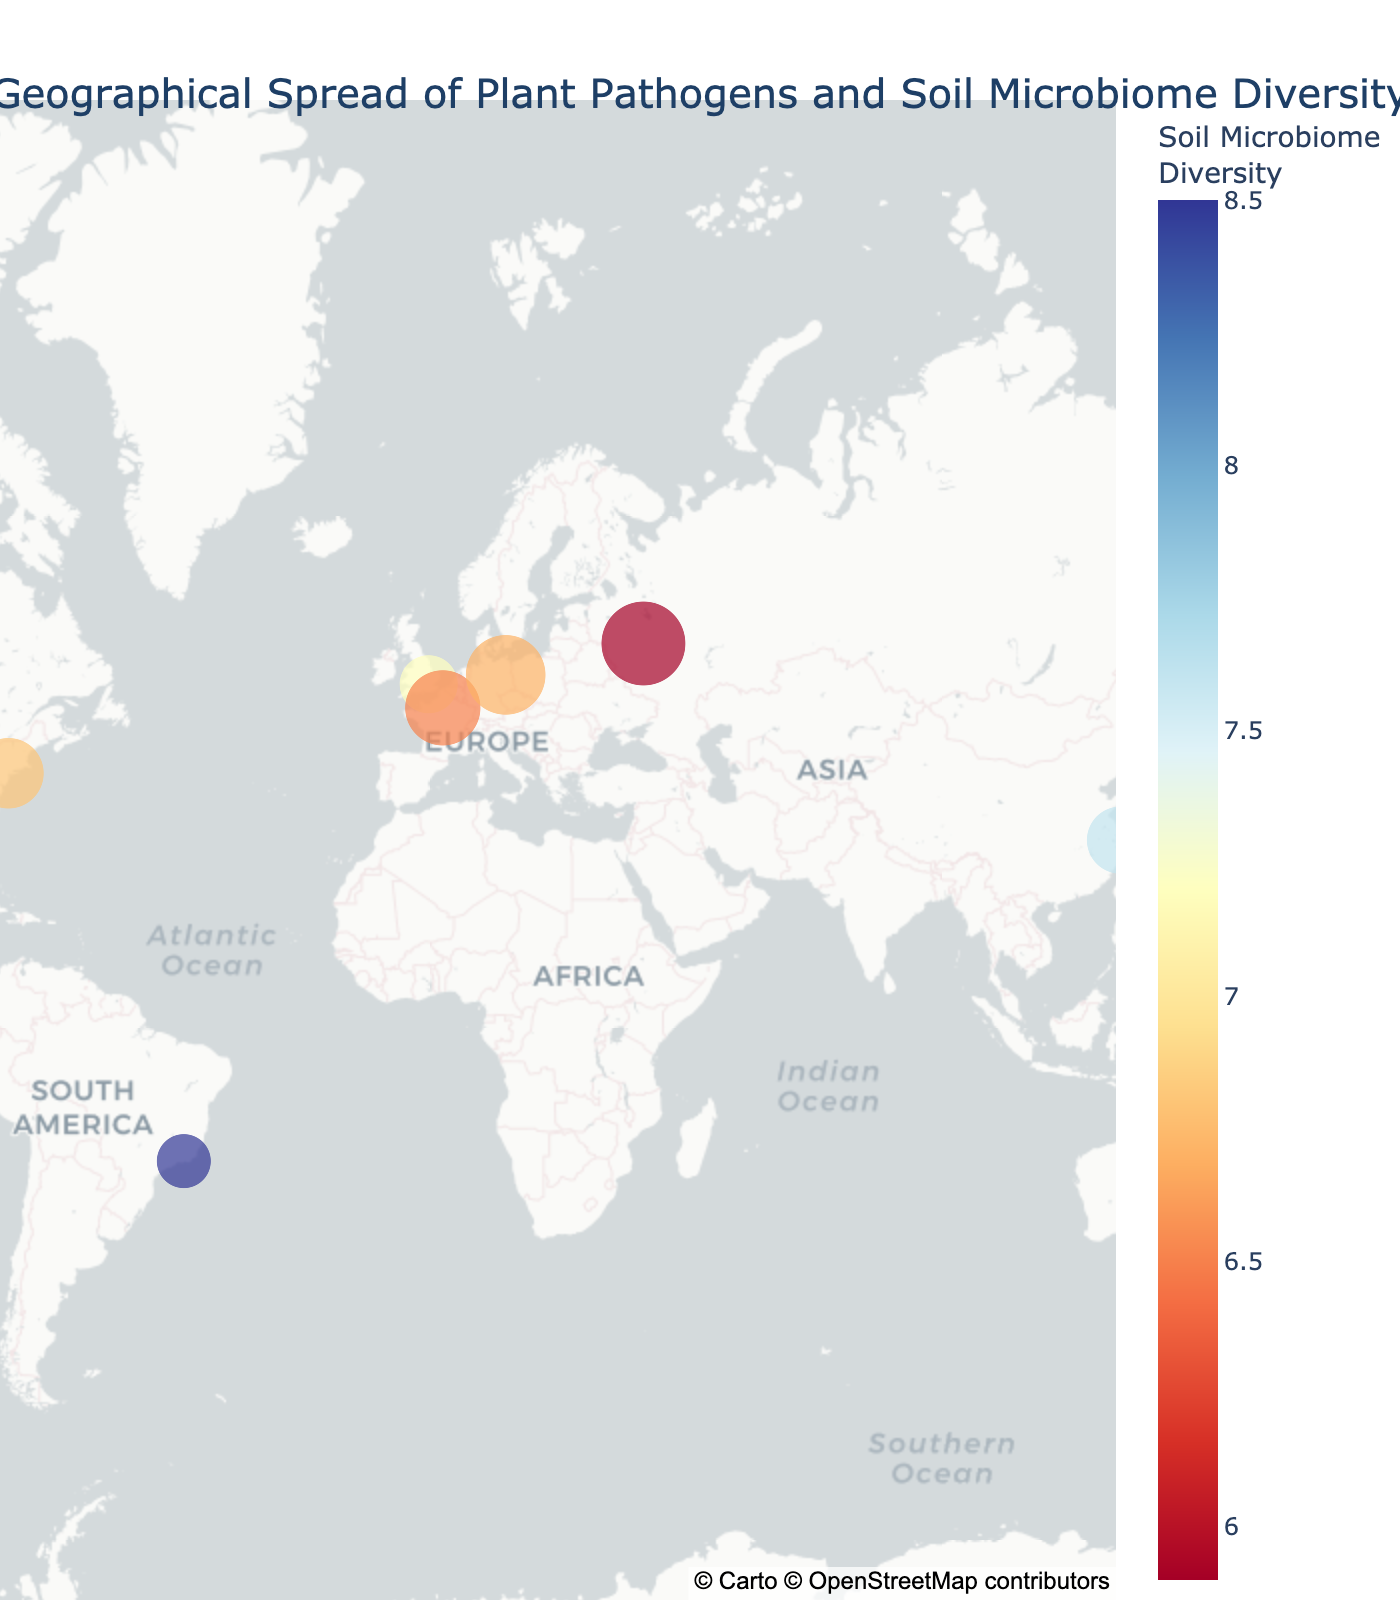What is the title of the plot? The title is displayed at the top of the plot, centered and slightly above the map. It provides a summary of the plot's content.
Answer: Geographical Spread of Plant Pathogens and Soil Microbiome Diversity How many data points are displayed on the map? Each data point represents a city with associated pathogen data, and these are visually represented as points on the map. By counting these points, we can find the total number.
Answer: 10 Which location has the highest soil microbiome diversity? Look for the data point with the highest value in the color scale representing soil microbiome diversity. The hover label can help identify the exact location.
Answer: Rio de Janeiro What is the infection rate for the pathogen in Sydney? Hover over the data point representing Sydney to display the additional information, which includes the infection rate for the pathogen in that location.
Answer: 0.18 Compare the soil microbiome diversity between London and New York. Which is higher? Hover over the data points for London and New York individually to see their soil microbiome diversity values. Compare the two values to determine which is higher.
Answer: London What is the sum of the infection rates for Berlin and Paris? First, obtain the infection rates for Berlin and Paris by hovering over those data points. Then, sum these rates to get the total. (Berlin: 0.28, Paris: 0.25)
Answer: 0.53 Which location has the lowest infection rate and what is the pathogen there? Look for the smallest data point size, indicating the lowest infection rate, then hover over that point to see the pathogen information.
Answer: Tokyo, Ralstonia solanacearum Is there a visible correlation between soil microbiome diversity and infection rate based on the data points on the plot? Observe the relationship between the color intensity (representing soil microbiome diversity) and the size of the data points (representing infection rate). High diversity with low infection rate or vice versa would suggest a correlation. To answer this, note any trends across the plot.
Answer: There appears to be a weak inverse correlation What pathogen is found in Moscow and what is its infection rate? Hover over the data point for Moscow to obtain information about the pathogen and the associated infection rate.
Answer: Puccinia graminis, 0.31 Which location has similar soil microbiome diversity but different infection rates compared to San Francisco? Compare the soil microbiome diversity values by hovering over various data points and identify those that are close to San Francisco's diversity (7.4). Then compare their infection rates.
Answer: Sydney 